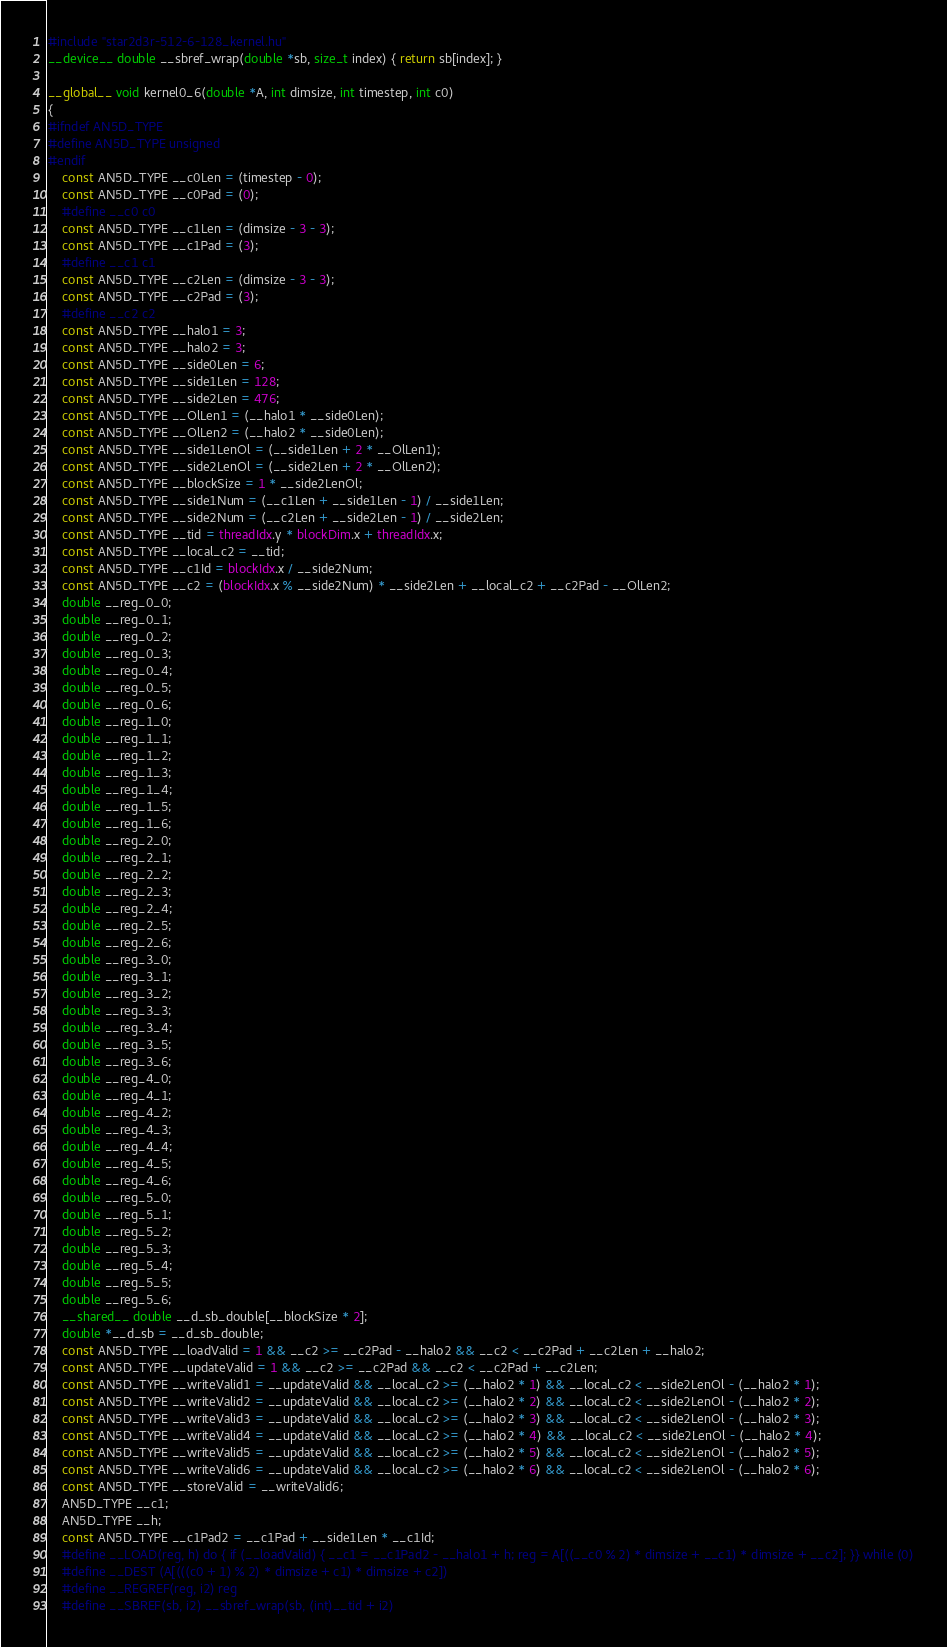Convert code to text. <code><loc_0><loc_0><loc_500><loc_500><_Cuda_>#include "star2d3r-512-6-128_kernel.hu"
__device__ double __sbref_wrap(double *sb, size_t index) { return sb[index]; }

__global__ void kernel0_6(double *A, int dimsize, int timestep, int c0)
{
#ifndef AN5D_TYPE
#define AN5D_TYPE unsigned
#endif
    const AN5D_TYPE __c0Len = (timestep - 0);
    const AN5D_TYPE __c0Pad = (0);
    #define __c0 c0
    const AN5D_TYPE __c1Len = (dimsize - 3 - 3);
    const AN5D_TYPE __c1Pad = (3);
    #define __c1 c1
    const AN5D_TYPE __c2Len = (dimsize - 3 - 3);
    const AN5D_TYPE __c2Pad = (3);
    #define __c2 c2
    const AN5D_TYPE __halo1 = 3;
    const AN5D_TYPE __halo2 = 3;
    const AN5D_TYPE __side0Len = 6;
    const AN5D_TYPE __side1Len = 128;
    const AN5D_TYPE __side2Len = 476;
    const AN5D_TYPE __OlLen1 = (__halo1 * __side0Len);
    const AN5D_TYPE __OlLen2 = (__halo2 * __side0Len);
    const AN5D_TYPE __side1LenOl = (__side1Len + 2 * __OlLen1);
    const AN5D_TYPE __side2LenOl = (__side2Len + 2 * __OlLen2);
    const AN5D_TYPE __blockSize = 1 * __side2LenOl;
    const AN5D_TYPE __side1Num = (__c1Len + __side1Len - 1) / __side1Len;
    const AN5D_TYPE __side2Num = (__c2Len + __side2Len - 1) / __side2Len;
    const AN5D_TYPE __tid = threadIdx.y * blockDim.x + threadIdx.x;
    const AN5D_TYPE __local_c2 = __tid;
    const AN5D_TYPE __c1Id = blockIdx.x / __side2Num;
    const AN5D_TYPE __c2 = (blockIdx.x % __side2Num) * __side2Len + __local_c2 + __c2Pad - __OlLen2;
    double __reg_0_0;
    double __reg_0_1;
    double __reg_0_2;
    double __reg_0_3;
    double __reg_0_4;
    double __reg_0_5;
    double __reg_0_6;
    double __reg_1_0;
    double __reg_1_1;
    double __reg_1_2;
    double __reg_1_3;
    double __reg_1_4;
    double __reg_1_5;
    double __reg_1_6;
    double __reg_2_0;
    double __reg_2_1;
    double __reg_2_2;
    double __reg_2_3;
    double __reg_2_4;
    double __reg_2_5;
    double __reg_2_6;
    double __reg_3_0;
    double __reg_3_1;
    double __reg_3_2;
    double __reg_3_3;
    double __reg_3_4;
    double __reg_3_5;
    double __reg_3_6;
    double __reg_4_0;
    double __reg_4_1;
    double __reg_4_2;
    double __reg_4_3;
    double __reg_4_4;
    double __reg_4_5;
    double __reg_4_6;
    double __reg_5_0;
    double __reg_5_1;
    double __reg_5_2;
    double __reg_5_3;
    double __reg_5_4;
    double __reg_5_5;
    double __reg_5_6;
    __shared__ double __d_sb_double[__blockSize * 2];
    double *__d_sb = __d_sb_double;
    const AN5D_TYPE __loadValid = 1 && __c2 >= __c2Pad - __halo2 && __c2 < __c2Pad + __c2Len + __halo2;
    const AN5D_TYPE __updateValid = 1 && __c2 >= __c2Pad && __c2 < __c2Pad + __c2Len;
    const AN5D_TYPE __writeValid1 = __updateValid && __local_c2 >= (__halo2 * 1) && __local_c2 < __side2LenOl - (__halo2 * 1);
    const AN5D_TYPE __writeValid2 = __updateValid && __local_c2 >= (__halo2 * 2) && __local_c2 < __side2LenOl - (__halo2 * 2);
    const AN5D_TYPE __writeValid3 = __updateValid && __local_c2 >= (__halo2 * 3) && __local_c2 < __side2LenOl - (__halo2 * 3);
    const AN5D_TYPE __writeValid4 = __updateValid && __local_c2 >= (__halo2 * 4) && __local_c2 < __side2LenOl - (__halo2 * 4);
    const AN5D_TYPE __writeValid5 = __updateValid && __local_c2 >= (__halo2 * 5) && __local_c2 < __side2LenOl - (__halo2 * 5);
    const AN5D_TYPE __writeValid6 = __updateValid && __local_c2 >= (__halo2 * 6) && __local_c2 < __side2LenOl - (__halo2 * 6);
    const AN5D_TYPE __storeValid = __writeValid6;
    AN5D_TYPE __c1;
    AN5D_TYPE __h;
    const AN5D_TYPE __c1Pad2 = __c1Pad + __side1Len * __c1Id;
    #define __LOAD(reg, h) do { if (__loadValid) { __c1 = __c1Pad2 - __halo1 + h; reg = A[((__c0 % 2) * dimsize + __c1) * dimsize + __c2]; }} while (0)
    #define __DEST (A[(((c0 + 1) % 2) * dimsize + c1) * dimsize + c2])
    #define __REGREF(reg, i2) reg
    #define __SBREF(sb, i2) __sbref_wrap(sb, (int)__tid + i2)</code> 